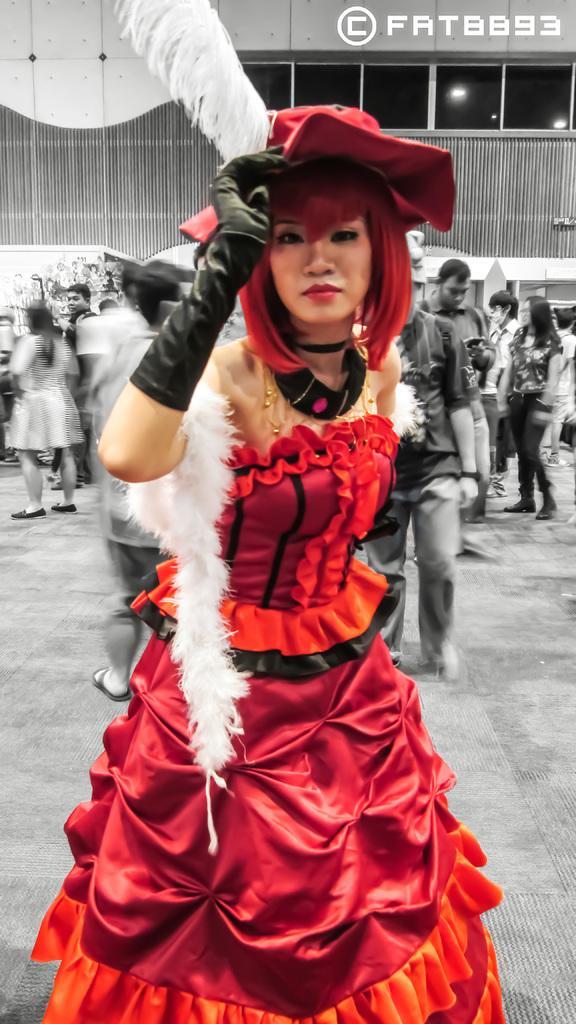Describe this image in one or two sentences. In this image we can see there are people walking on the ground. And at the back there is a building with fence and window. 